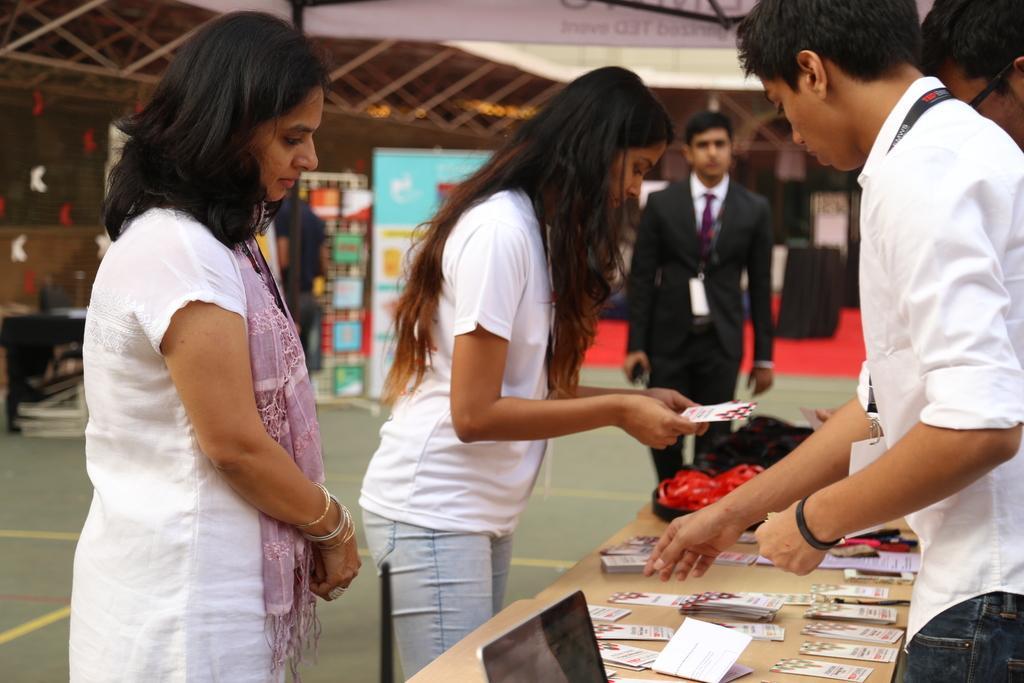Please provide a concise description of this image. There are two ladies standing. A lady in the left corner is wearing a scarf. And another lady is holding a paper. A man is in the right side is having a tag. In front of him there is a table. On the table there is a laptop and some papers are kept over there. And another man wearing a black dress is walking. In the background there are wall and some other items kept. 